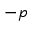<formula> <loc_0><loc_0><loc_500><loc_500>- p</formula> 